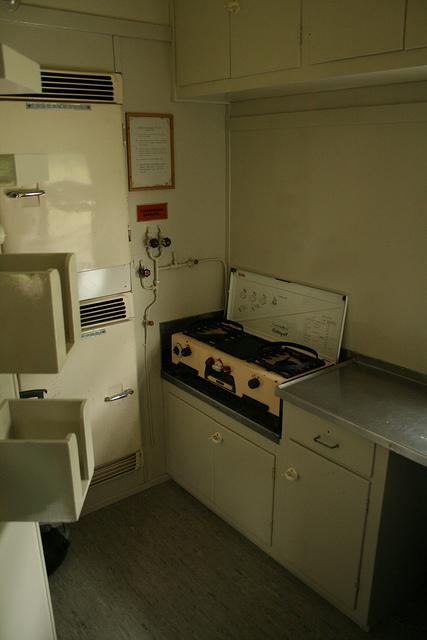How many bottles are on the shelf?
Write a very short answer. 0. Is there a light on in this room?
Quick response, please. No. How many cabinets are visible?
Concise answer only. 4. Are the walls one color?
Write a very short answer. Yes. Is there a paper lamp hanging from the ceiling?
Keep it brief. No. Are the floors a checkerboard pattern?
Be succinct. No. What is the name of this room?
Concise answer only. Kitchen. What is this room used for?
Give a very brief answer. Cooking. Is this a modern kitchen?
Short answer required. No. Is there a printer?
Short answer required. No. What color is the wall?
Concise answer only. White. Is the room empty?
Answer briefly. Yes. What appliance is that?
Answer briefly. Stove. Are there any lights on?
Quick response, please. No. Is a microwave?
Be succinct. No. What picture is on the wall?
Keep it brief. Certificate. What room was this picture taken in?
Give a very brief answer. Kitchen. Is there a visible window?
Quick response, please. No. Is there a mirror here?
Answer briefly. No. How old are the cabinets in this room?
Keep it brief. Very old. What room are they in?
Write a very short answer. Kitchen. What kind of stove is pictured?
Answer briefly. Gas. What would be something stored in a cabinet here?
Answer briefly. Food. Do these items contain a battery?
Keep it brief. No. What is this room?
Short answer required. Kitchen. What room is this?
Concise answer only. Kitchen. 